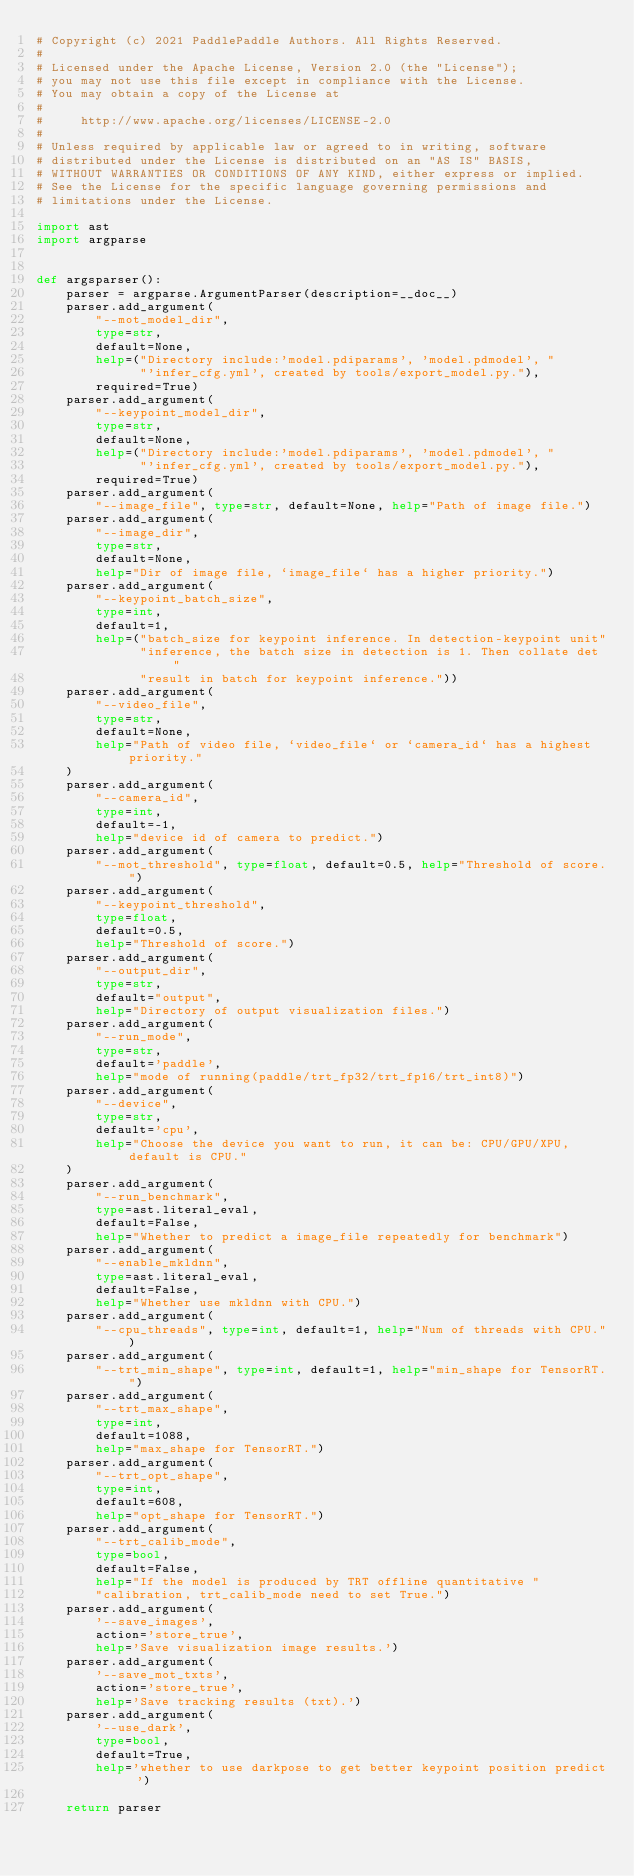Convert code to text. <code><loc_0><loc_0><loc_500><loc_500><_Python_># Copyright (c) 2021 PaddlePaddle Authors. All Rights Reserved.
#
# Licensed under the Apache License, Version 2.0 (the "License");
# you may not use this file except in compliance with the License.
# You may obtain a copy of the License at
#
#     http://www.apache.org/licenses/LICENSE-2.0
#
# Unless required by applicable law or agreed to in writing, software
# distributed under the License is distributed on an "AS IS" BASIS,
# WITHOUT WARRANTIES OR CONDITIONS OF ANY KIND, either express or implied.
# See the License for the specific language governing permissions and
# limitations under the License.

import ast
import argparse


def argsparser():
    parser = argparse.ArgumentParser(description=__doc__)
    parser.add_argument(
        "--mot_model_dir",
        type=str,
        default=None,
        help=("Directory include:'model.pdiparams', 'model.pdmodel', "
              "'infer_cfg.yml', created by tools/export_model.py."),
        required=True)
    parser.add_argument(
        "--keypoint_model_dir",
        type=str,
        default=None,
        help=("Directory include:'model.pdiparams', 'model.pdmodel', "
              "'infer_cfg.yml', created by tools/export_model.py."),
        required=True)
    parser.add_argument(
        "--image_file", type=str, default=None, help="Path of image file.")
    parser.add_argument(
        "--image_dir",
        type=str,
        default=None,
        help="Dir of image file, `image_file` has a higher priority.")
    parser.add_argument(
        "--keypoint_batch_size",
        type=int,
        default=1,
        help=("batch_size for keypoint inference. In detection-keypoint unit"
              "inference, the batch size in detection is 1. Then collate det "
              "result in batch for keypoint inference."))
    parser.add_argument(
        "--video_file",
        type=str,
        default=None,
        help="Path of video file, `video_file` or `camera_id` has a highest priority."
    )
    parser.add_argument(
        "--camera_id",
        type=int,
        default=-1,
        help="device id of camera to predict.")
    parser.add_argument(
        "--mot_threshold", type=float, default=0.5, help="Threshold of score.")
    parser.add_argument(
        "--keypoint_threshold",
        type=float,
        default=0.5,
        help="Threshold of score.")
    parser.add_argument(
        "--output_dir",
        type=str,
        default="output",
        help="Directory of output visualization files.")
    parser.add_argument(
        "--run_mode",
        type=str,
        default='paddle',
        help="mode of running(paddle/trt_fp32/trt_fp16/trt_int8)")
    parser.add_argument(
        "--device",
        type=str,
        default='cpu',
        help="Choose the device you want to run, it can be: CPU/GPU/XPU, default is CPU."
    )
    parser.add_argument(
        "--run_benchmark",
        type=ast.literal_eval,
        default=False,
        help="Whether to predict a image_file repeatedly for benchmark")
    parser.add_argument(
        "--enable_mkldnn",
        type=ast.literal_eval,
        default=False,
        help="Whether use mkldnn with CPU.")
    parser.add_argument(
        "--cpu_threads", type=int, default=1, help="Num of threads with CPU.")
    parser.add_argument(
        "--trt_min_shape", type=int, default=1, help="min_shape for TensorRT.")
    parser.add_argument(
        "--trt_max_shape",
        type=int,
        default=1088,
        help="max_shape for TensorRT.")
    parser.add_argument(
        "--trt_opt_shape",
        type=int,
        default=608,
        help="opt_shape for TensorRT.")
    parser.add_argument(
        "--trt_calib_mode",
        type=bool,
        default=False,
        help="If the model is produced by TRT offline quantitative "
        "calibration, trt_calib_mode need to set True.")
    parser.add_argument(
        '--save_images',
        action='store_true',
        help='Save visualization image results.')
    parser.add_argument(
        '--save_mot_txts',
        action='store_true',
        help='Save tracking results (txt).')
    parser.add_argument(
        '--use_dark',
        type=bool,
        default=True,
        help='whether to use darkpose to get better keypoint position predict ')

    return parser
</code> 